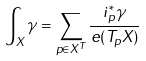Convert formula to latex. <formula><loc_0><loc_0><loc_500><loc_500>\int _ { X } \gamma = \sum _ { p \in X ^ { T } } \frac { i _ { p } ^ { * } \gamma } { e ( T _ { p } X ) }</formula> 